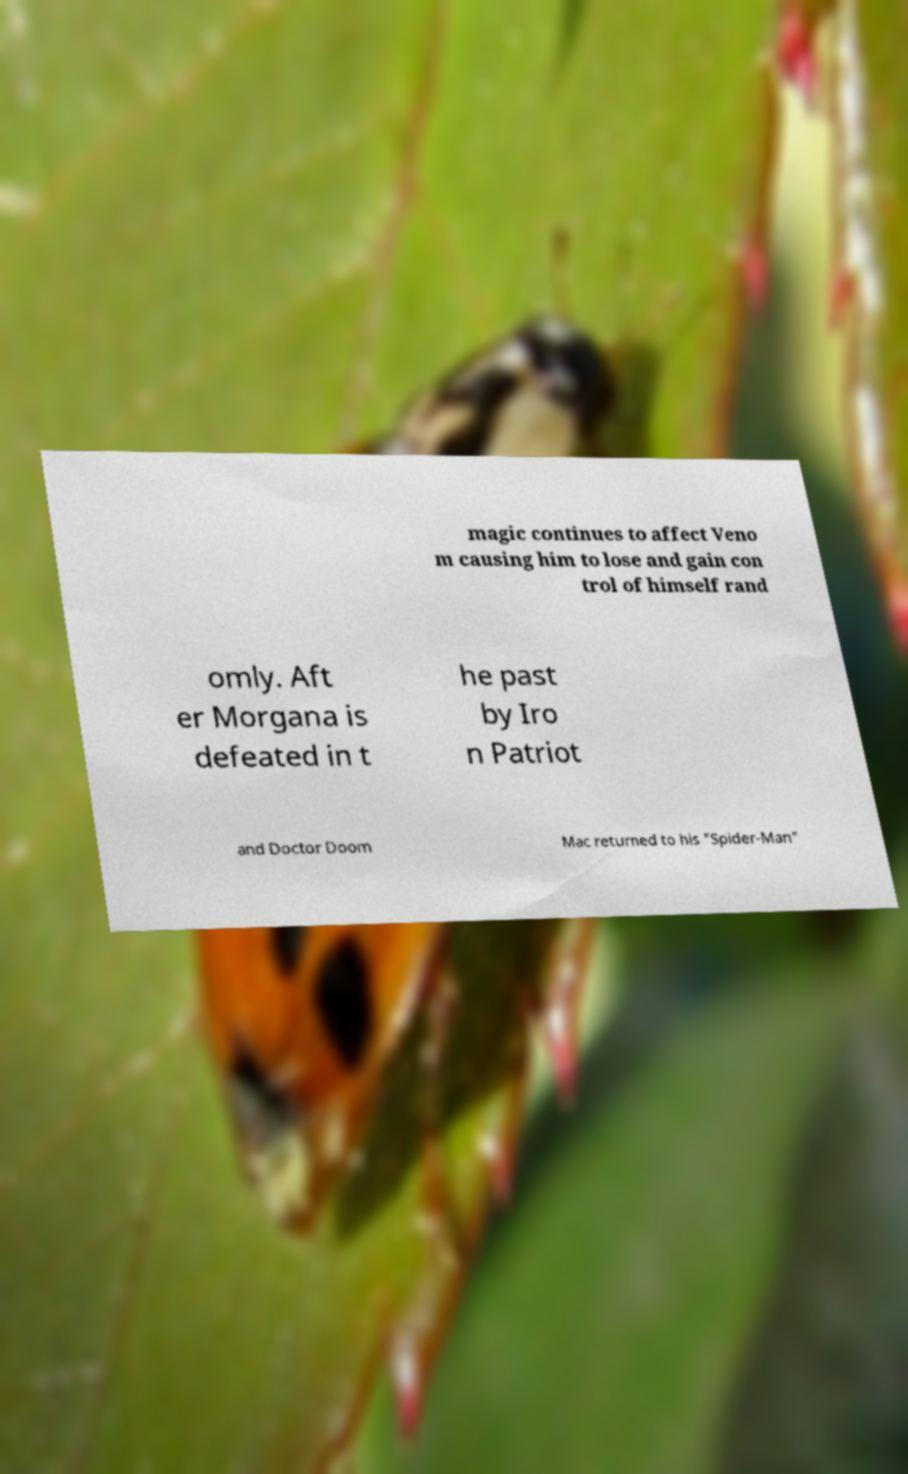Can you accurately transcribe the text from the provided image for me? magic continues to affect Veno m causing him to lose and gain con trol of himself rand omly. Aft er Morgana is defeated in t he past by Iro n Patriot and Doctor Doom Mac returned to his "Spider-Man" 